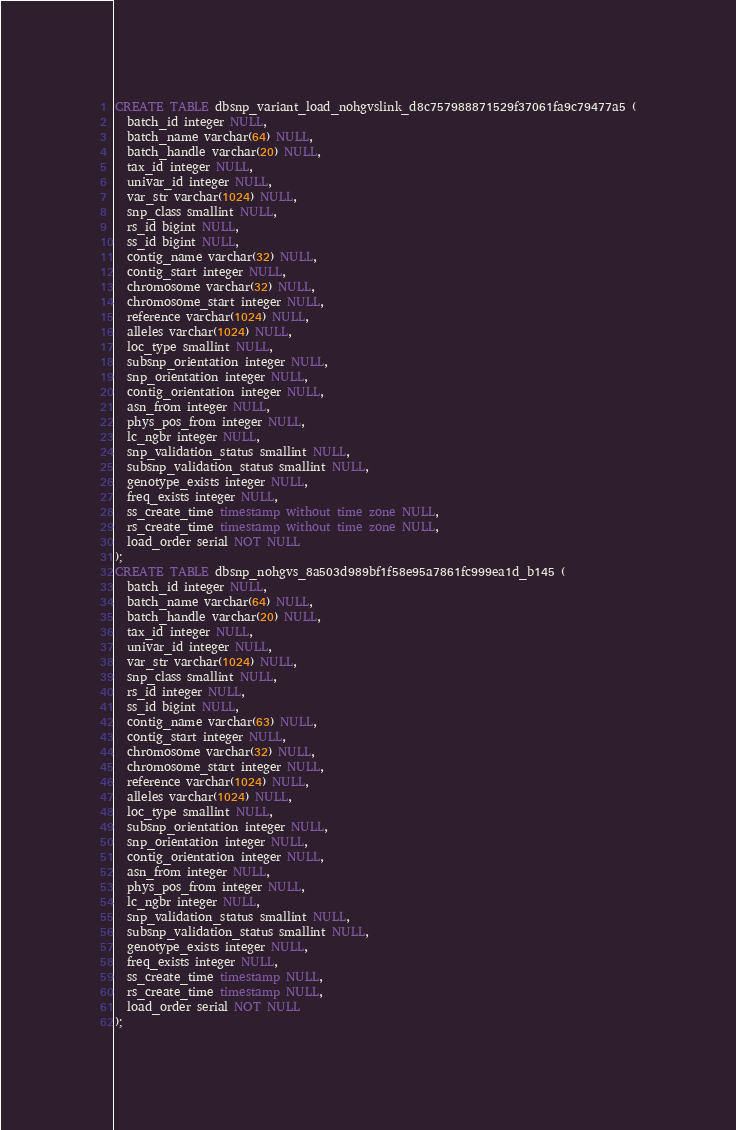Convert code to text. <code><loc_0><loc_0><loc_500><loc_500><_SQL_>CREATE TABLE dbsnp_variant_load_nohgvslink_d8c757988871529f37061fa9c79477a5 (
  batch_id integer NULL,
  batch_name varchar(64) NULL,
  batch_handle varchar(20) NULL,
  tax_id integer NULL,
  univar_id integer NULL,
  var_str varchar(1024) NULL,
  snp_class smallint NULL,
  rs_id bigint NULL,
  ss_id bigint NULL,
  contig_name varchar(32) NULL,
  contig_start integer NULL,
  chromosome varchar(32) NULL,
  chromosome_start integer NULL,
  reference varchar(1024) NULL,
  alleles varchar(1024) NULL,
  loc_type smallint NULL,
  subsnp_orientation integer NULL,
  snp_orientation integer NULL,
  contig_orientation integer NULL,
  asn_from integer NULL,
  phys_pos_from integer NULL,
  lc_ngbr integer NULL,
  snp_validation_status smallint NULL,
  subsnp_validation_status smallint NULL,
  genotype_exists integer NULL,
  freq_exists integer NULL,
  ss_create_time timestamp without time zone NULL,
  rs_create_time timestamp without time zone NULL,
  load_order serial NOT NULL
);
CREATE TABLE dbsnp_nohgvs_8a503d989bf1f58e95a7861fc999ea1d_b145 (
  batch_id integer NULL,
  batch_name varchar(64) NULL,
  batch_handle varchar(20) NULL,
  tax_id integer NULL,
  univar_id integer NULL,
  var_str varchar(1024) NULL,
  snp_class smallint NULL,
  rs_id integer NULL,
  ss_id bigint NULL,
  contig_name varchar(63) NULL,
  contig_start integer NULL,
  chromosome varchar(32) NULL,
  chromosome_start integer NULL,
  reference varchar(1024) NULL,
  alleles varchar(1024) NULL,
  loc_type smallint NULL,
  subsnp_orientation integer NULL,
  snp_orientation integer NULL,
  contig_orientation integer NULL,
  asn_from integer NULL,
  phys_pos_from integer NULL,
  lc_ngbr integer NULL,
  snp_validation_status smallint NULL,
  subsnp_validation_status smallint NULL,
  genotype_exists integer NULL,
  freq_exists integer NULL,
  ss_create_time timestamp NULL,
  rs_create_time timestamp NULL,
  load_order serial NOT NULL
);</code> 